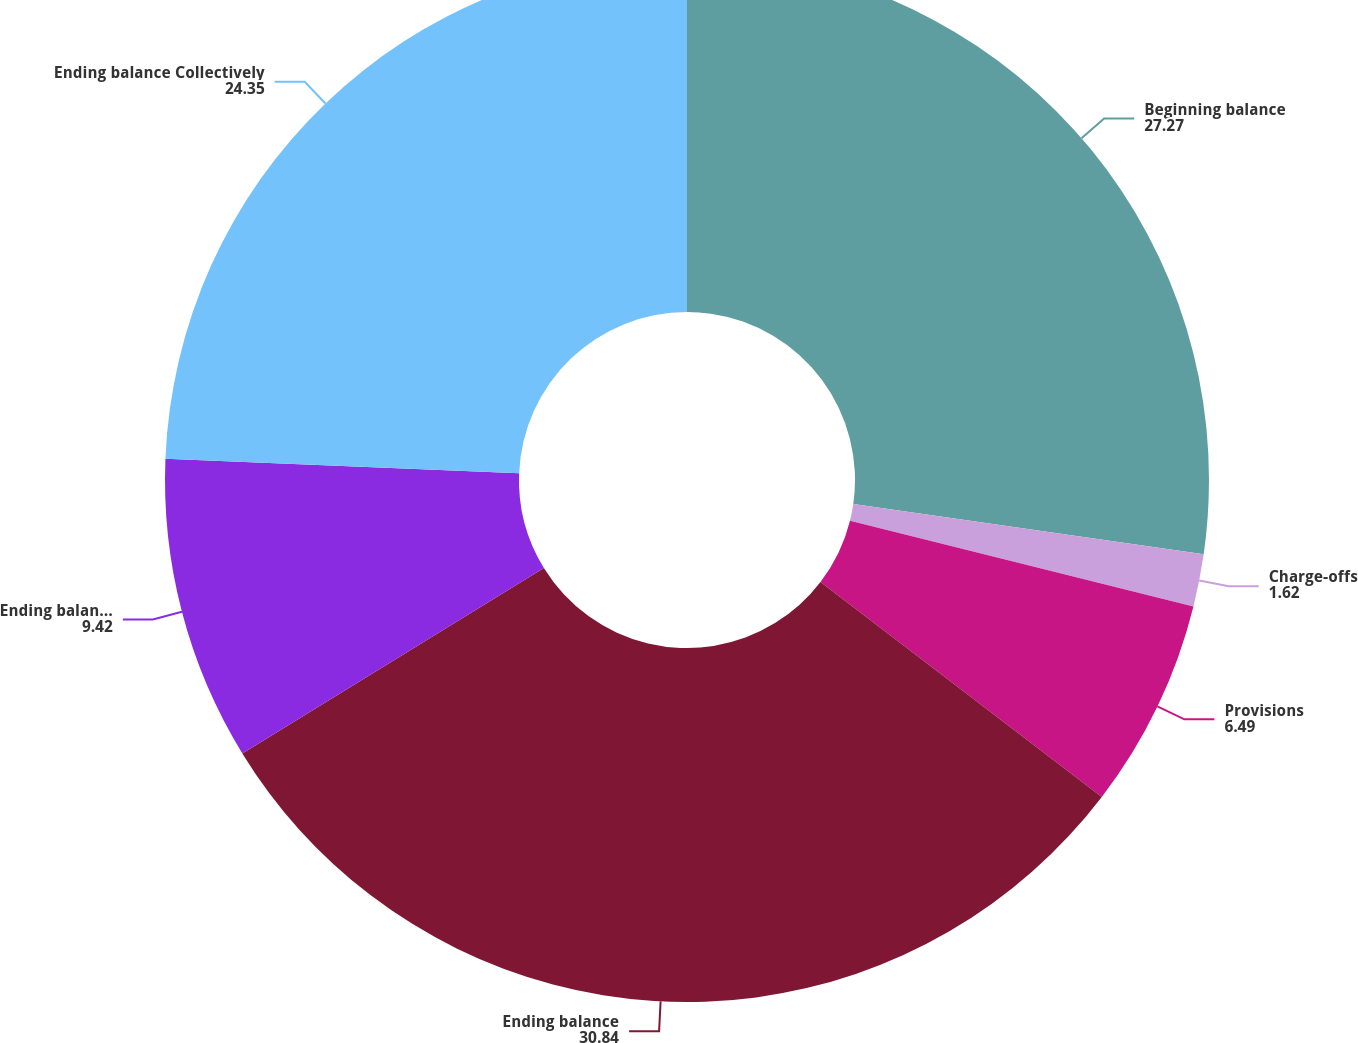<chart> <loc_0><loc_0><loc_500><loc_500><pie_chart><fcel>Beginning balance<fcel>Charge-offs<fcel>Provisions<fcel>Ending balance<fcel>Ending balance Individually<fcel>Ending balance Collectively<nl><fcel>27.27%<fcel>1.62%<fcel>6.49%<fcel>30.84%<fcel>9.42%<fcel>24.35%<nl></chart> 